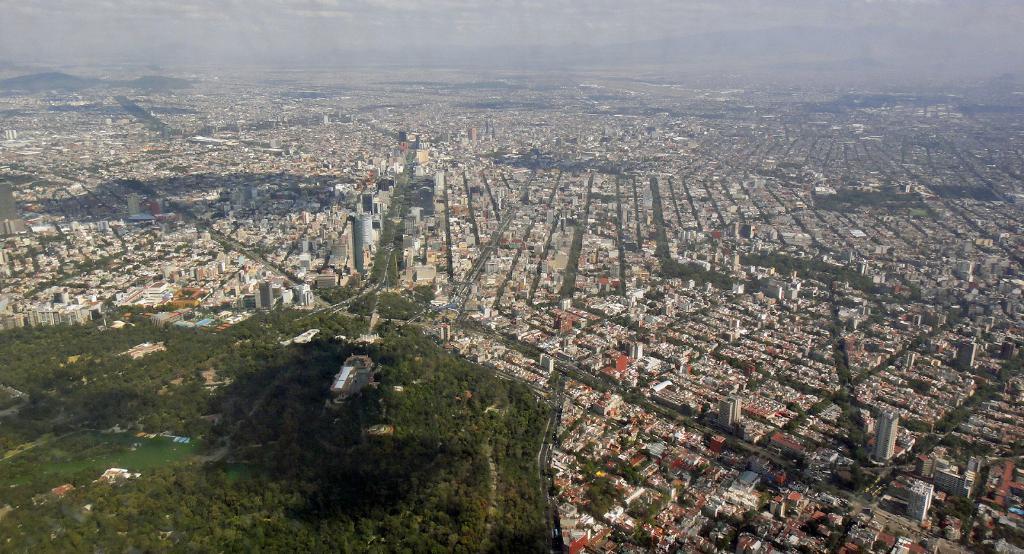How would you summarize this image in a sentence or two? To the bottom left of the image there are many trees and also there is water in the middle of the trees. There are many buildings, trees and also there are many lanes. In the background there are many hills. 